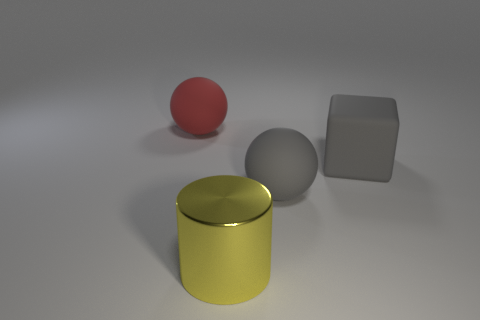There is a big red ball behind the sphere that is right of the big red sphere; what number of matte objects are behind it?
Keep it short and to the point. 0. There is a object that is behind the gray rubber sphere and to the right of the yellow metallic cylinder; what shape is it?
Provide a succinct answer. Cube. Are there fewer large gray rubber cubes that are on the left side of the large cube than tiny rubber cylinders?
Ensure brevity in your answer.  No. What number of small things are matte balls or gray rubber cylinders?
Keep it short and to the point. 0. The yellow metallic cylinder has what size?
Your answer should be compact. Large. Is there anything else that has the same material as the large yellow cylinder?
Offer a terse response. No. There is a large gray matte cube; how many red spheres are on the left side of it?
Provide a short and direct response. 1. What is the size of the gray rubber object that is the same shape as the big red object?
Ensure brevity in your answer.  Large. What is the size of the thing that is right of the red rubber ball and behind the gray sphere?
Offer a terse response. Large. There is a block; is its color the same as the large thing to the left of the metallic cylinder?
Your answer should be very brief. No. 